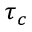<formula> <loc_0><loc_0><loc_500><loc_500>\tau _ { c }</formula> 